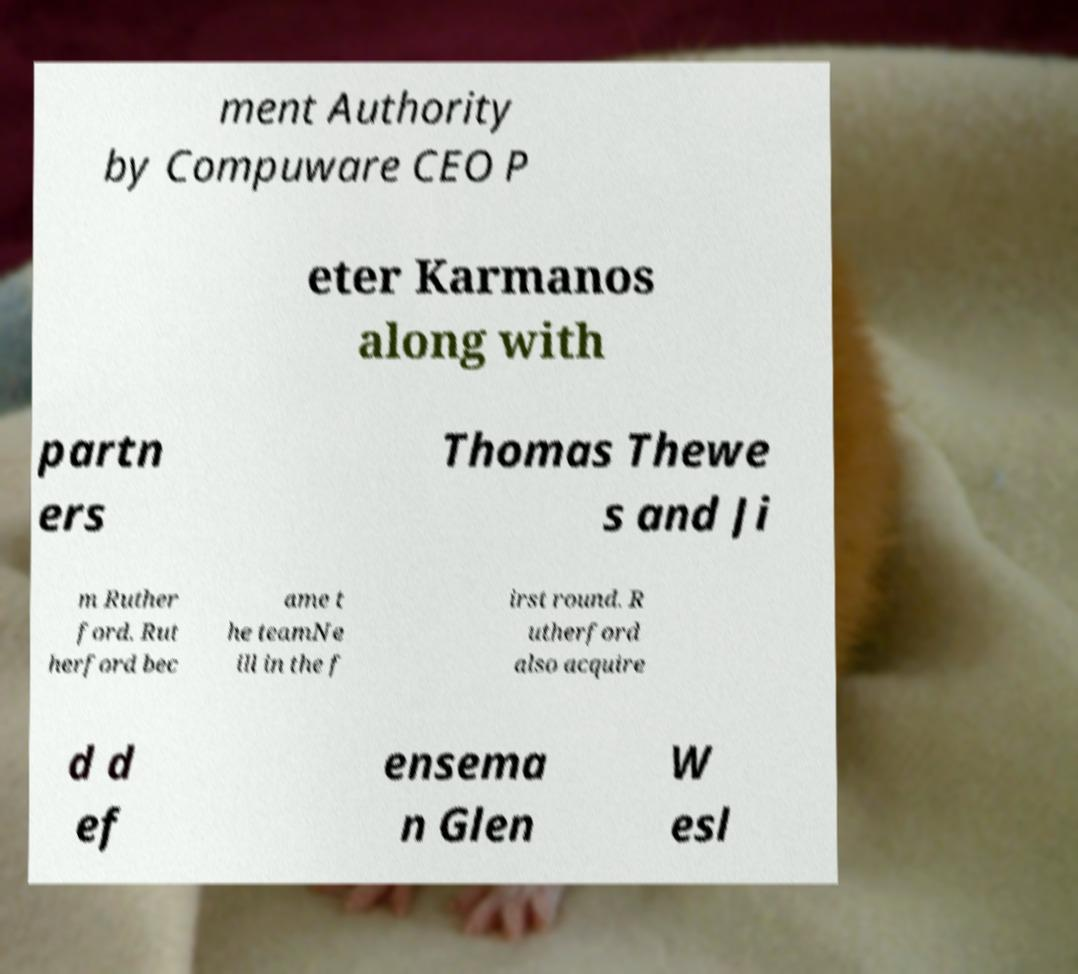Could you extract and type out the text from this image? ment Authority by Compuware CEO P eter Karmanos along with partn ers Thomas Thewe s and Ji m Ruther ford. Rut herford bec ame t he teamNe ill in the f irst round. R utherford also acquire d d ef ensema n Glen W esl 